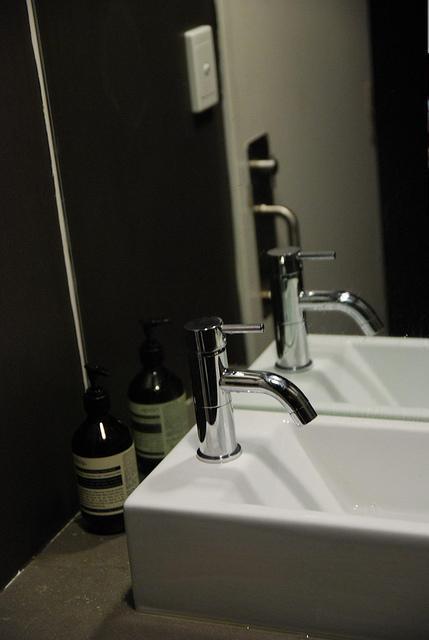How many sinks are there?
Give a very brief answer. 2. How many bottles are there?
Give a very brief answer. 2. 